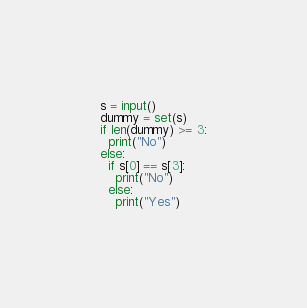Convert code to text. <code><loc_0><loc_0><loc_500><loc_500><_Python_>s = input()
dummy = set(s)
if len(dummy) >= 3:
  print("No")
else:
  if s[0] == s[3]:
    print("No")
  else:
    print("Yes")

</code> 